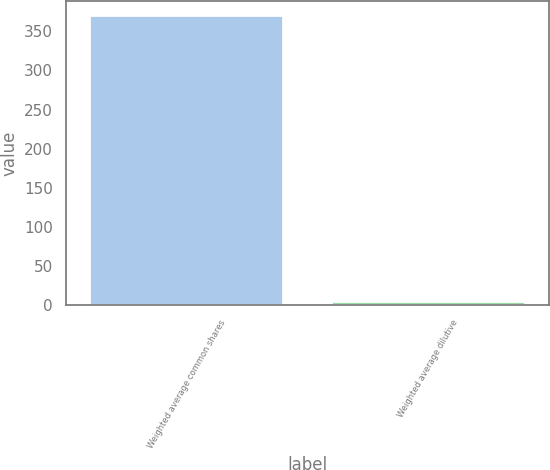<chart> <loc_0><loc_0><loc_500><loc_500><bar_chart><fcel>Weighted average common shares<fcel>Weighted average dilutive<nl><fcel>369.49<fcel>4<nl></chart> 